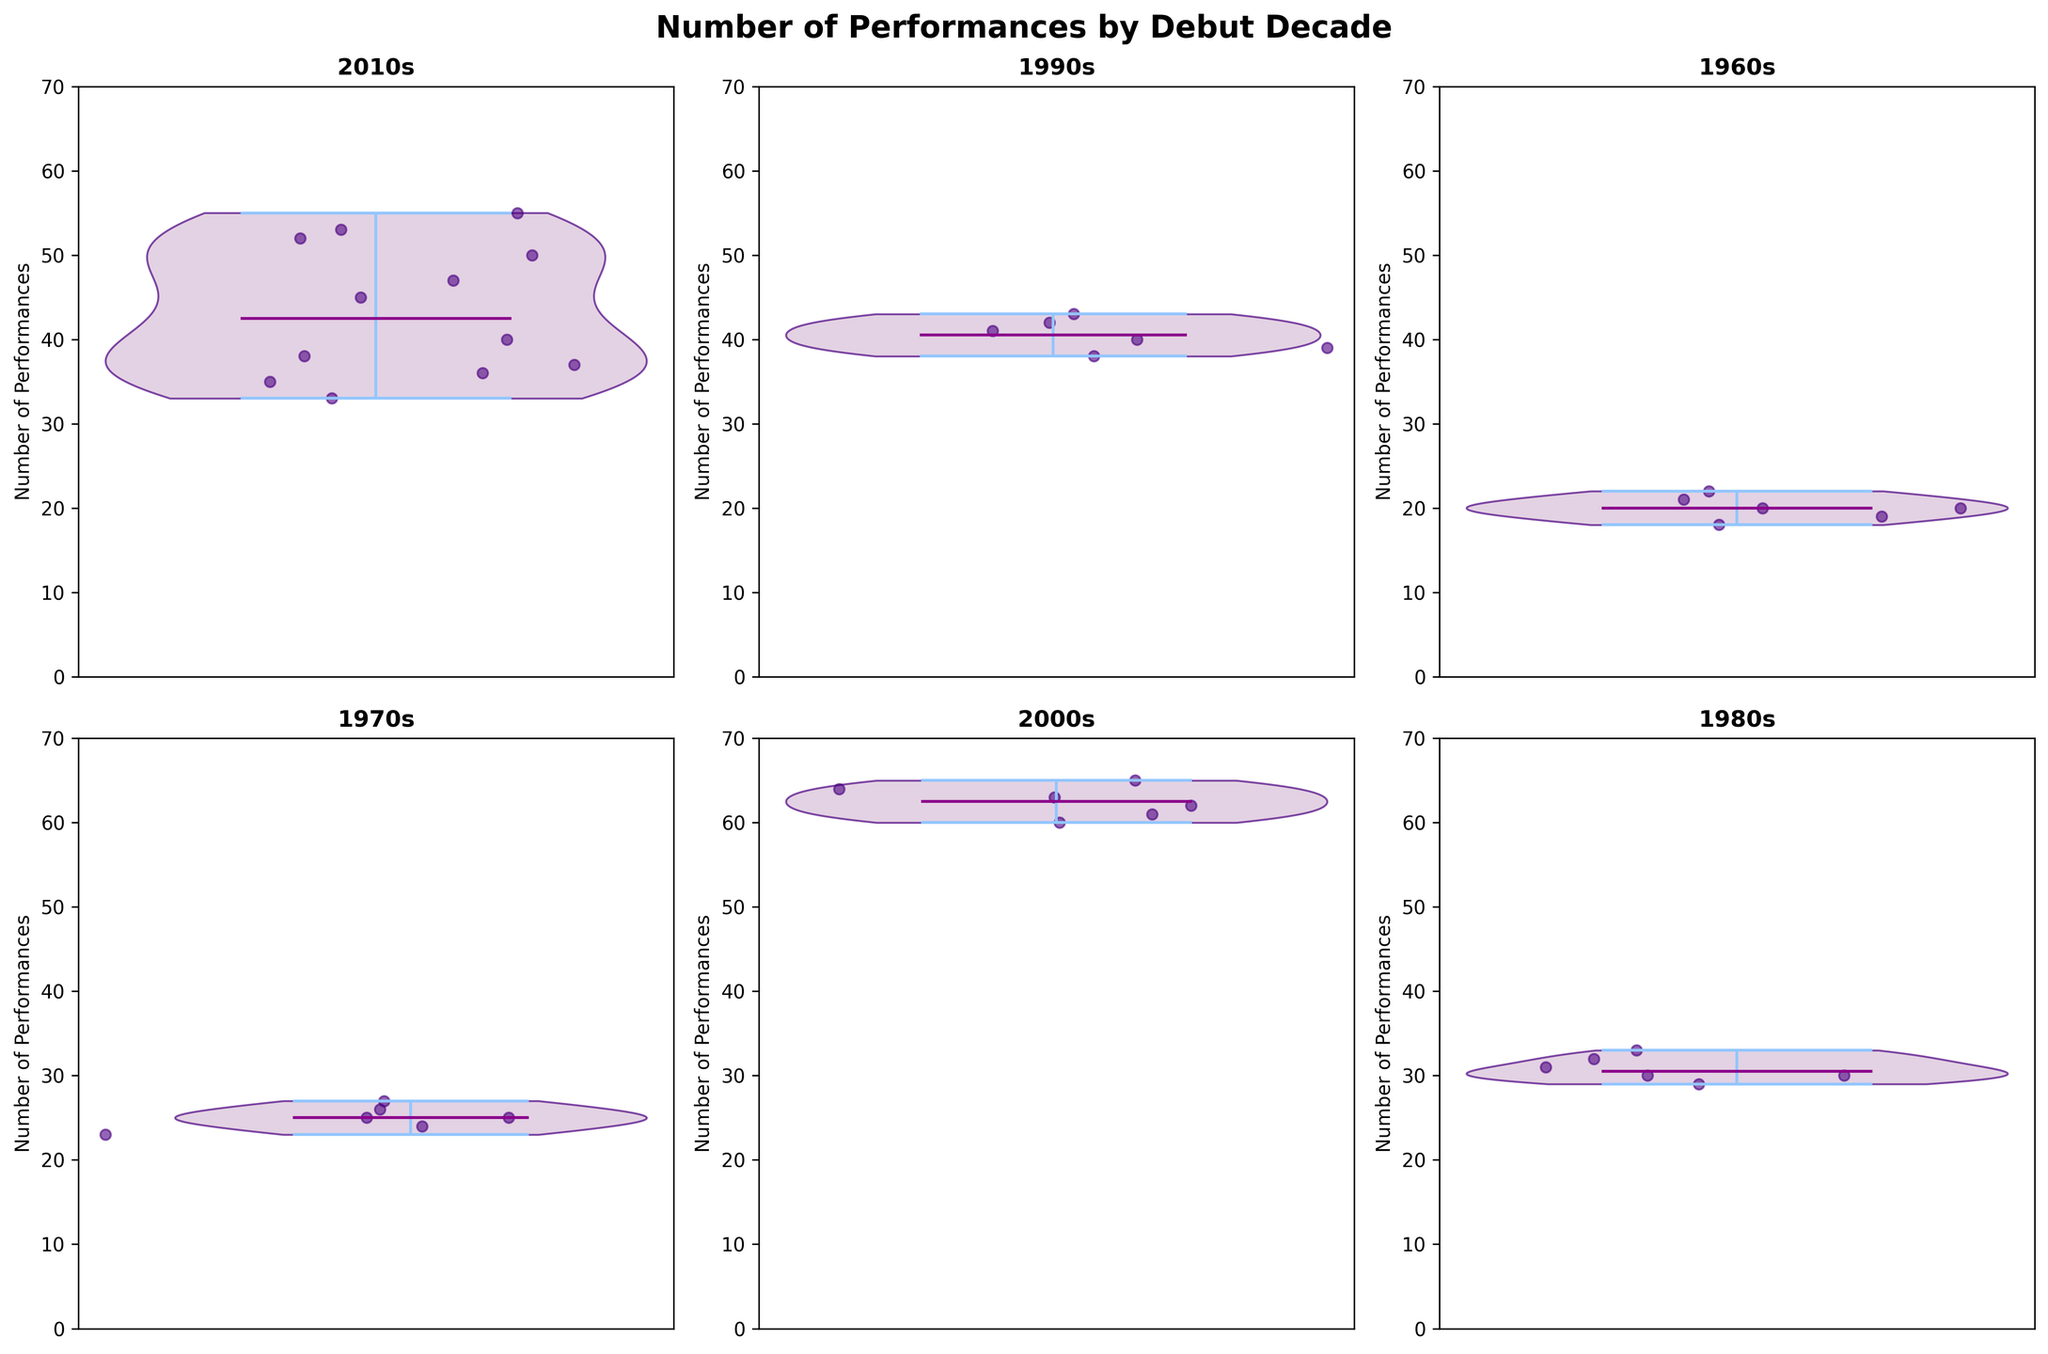What is the title of the figure? At the top of the figure, there’s a text stating "Number of Performances by Debut Decade" in bold.
Answer: Number of Performances by Debut Decade How many subplots are there in total? There are six slots for subplots based on the grid structure created by 2 rows and 3 columns.
Answer: 6 Which decade has a subplot with the highest median number of performances? The subplot titles represent different debut decades, and the median is indicated by a distinct line within each violin plot. The 2000s subplot shows a higher median line compared to the others.
Answer: 2000s What is the range of number of performances for Elton John in the 1960s subplot? By observing the height of the violin plot for the 1960s, the lowest point is 18 and the highest point is 22.
Answer: 18 to 22 How does the spread of performances compare between the 2010s and 1980s subplots? By comparing the width of the violin plots, the 2010s has a wider spread (more variability) compared to the 1980s, which indicates a more consistent number of performances.
Answer: 2010s have more variability Which subplot indicates a single outlier point closest to 36 performances? Check each subplot for scatter points around 36. The 2010s subplot has an outlier point around 36 for Dua Lipa.
Answer: 2010s What is the common color theme used in all violin plots? All the violin plots have a lavender-like color shading for the filled area and the edges are colored in a deep indigo.
Answer: Lavender and indigo Which decade's subplot has the fewest number of performances? The peaks of each subplot reveal that the 1960s subplot for Elton John indicates the fewest performances ranging from 18 to 22.
Answer: 1960s Does any debut decade's violin plot show overlapping values with another decade? By closely comparing the violin plots, the 1980s and 1990s have overlapping ranges of performances.
Answer: 1980s and 1990s 